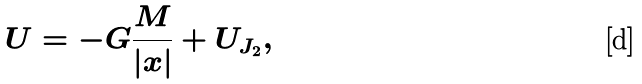<formula> <loc_0><loc_0><loc_500><loc_500>U = - G \frac { M } { | { x } | } + U _ { J _ { 2 } } ,</formula> 